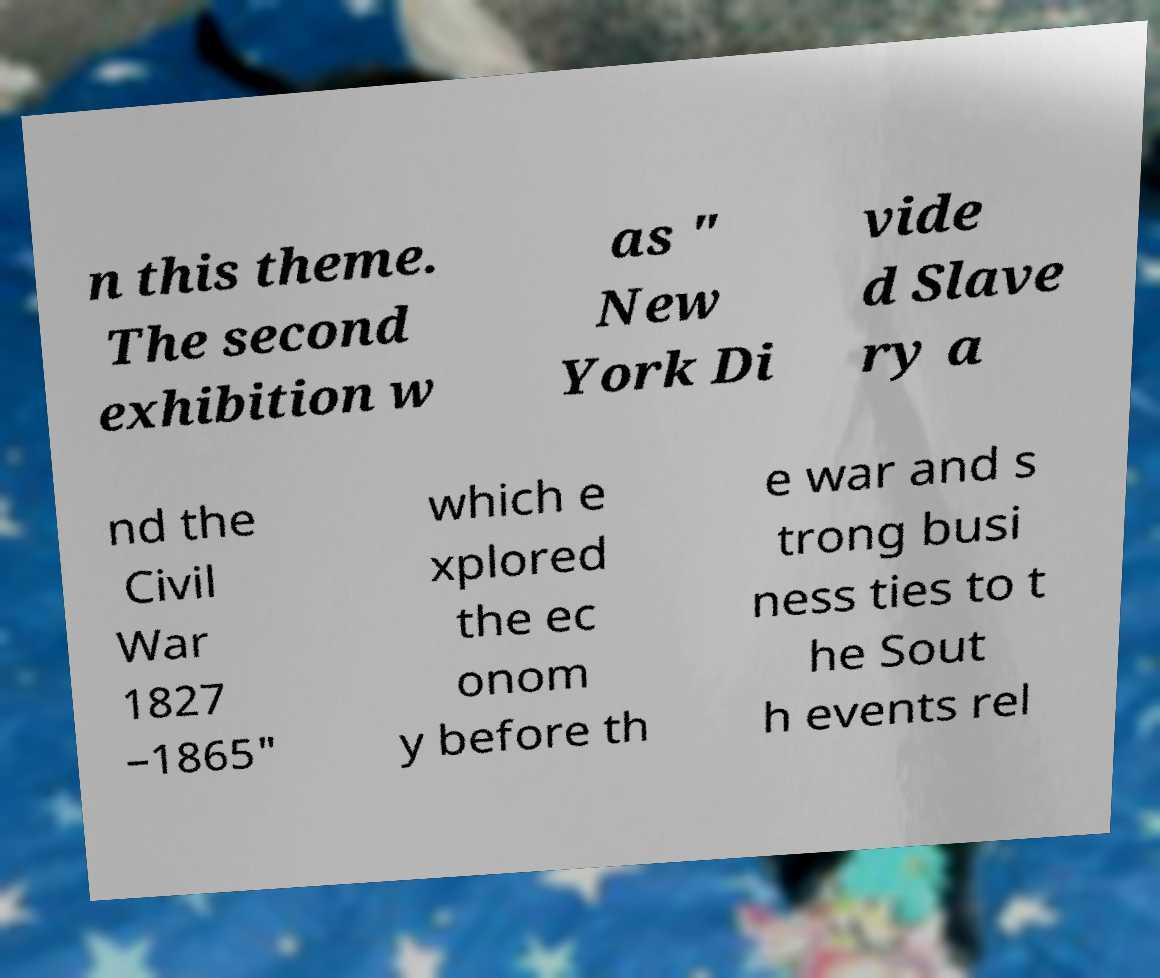There's text embedded in this image that I need extracted. Can you transcribe it verbatim? n this theme. The second exhibition w as " New York Di vide d Slave ry a nd the Civil War 1827 –1865" which e xplored the ec onom y before th e war and s trong busi ness ties to t he Sout h events rel 